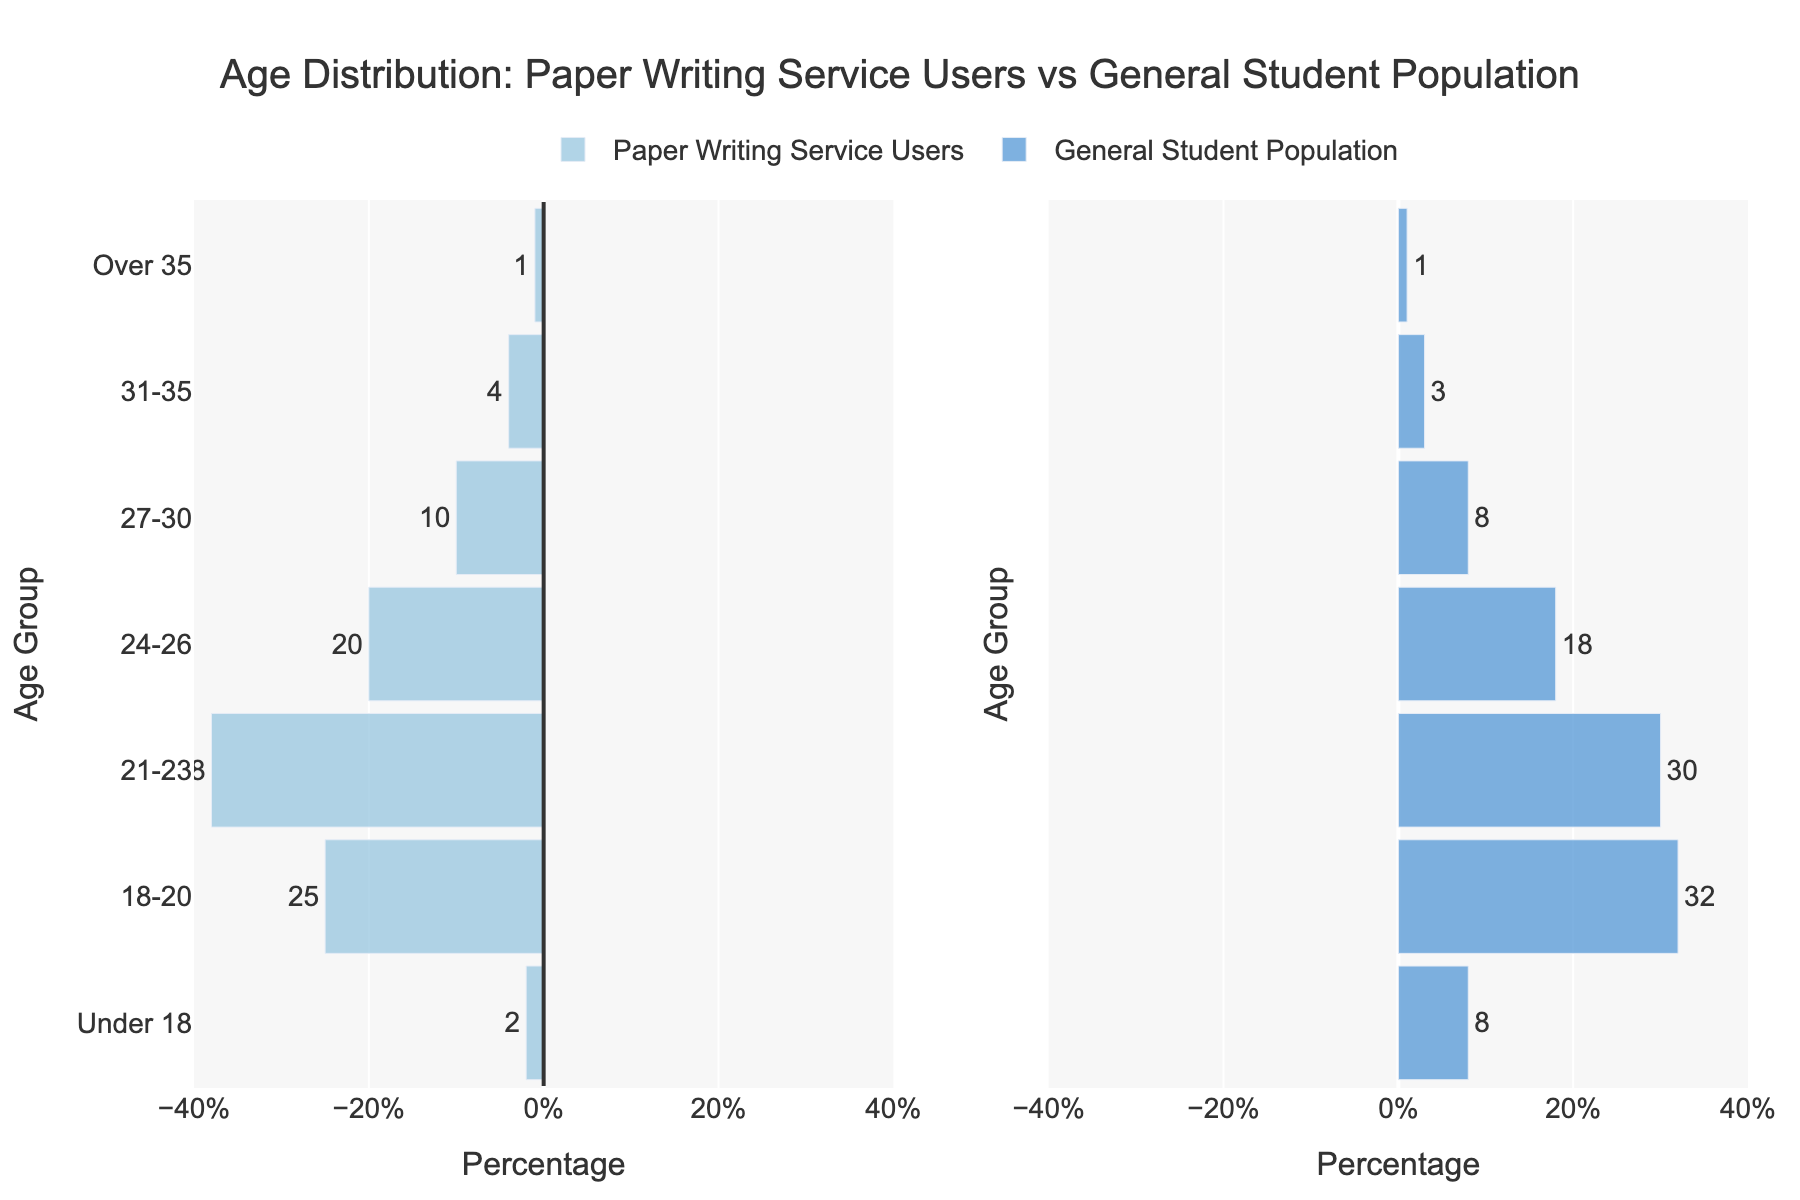what is the title of the figure? The title is displayed at the top of the figure, indicated with larger and bolder text. It summarizes what the figure is about.
Answer: Age Distribution: Paper Writing Service Users vs General Student Population How does the proportion of 18-20-year-old users of paper writing services compare to the general student population in the same age group? The bar for 18-20-year-olds in the Paper Writing Service Users category appears shorter than the bar for the same age group in the General Student Population. By comparing the numerical values, we see that 25% of paper writing service users are 18-20 years old, while 32% of the general student population falls within this age range.
Answer: Lower What is the difference in the percentage of 21-23-year-olds between the two groups? By looking at the length and values of the bars for the 21-23 age group, the Paper Writing Service Users have a percentage of 38%, while the General Student Population has 30%. Subtracting these two values (38 - 30) gives us the difference.
Answer: 8% Which age group has the smallest representation among paper writing service users? By examining the lengths of the bars within the Paper Writing Service Users category, the bar for the "Over 35" age group is the shortest, indicating the smallest percentage.
Answer: Over 35 What percentage of users of paper writing services are 24-30 years old? To find the total percentage of users aged 24-26 and 27-30, add their individual percentages. The figure shows 20% for 24-26-year-olds and 10% for 27-30-year-olds, summing up to 30%.
Answer: 30% Do older students (31 years and older) use paper writing services more or less than the general student population? Observing the bars for the "31-35" and "Over 35" age groups in both categories, we see that in Paper Writing Service Users, the percentages are 4% and 1%, respectively. For the General Student Population, the percentages are 3% and 1%, respectively. By comparing these percentages, we conclude that users of paper writing services actually use them more in the 31-35 age range but equally in the Over 35 range.
Answer: More for 31-35, Equal for Over 35 Which age group shows the biggest discrepancy in percentage between the two populations? By comparing the absolute differences for each age group, the difference is found by subtracting the smaller percentage from the larger for each age group. The largest difference can be easily seen in the figure by the relative lengths of the bars. 18-20 has the largest difference of 7% (32 - 25).
Answer: 18-20 Is there any age group where both populations have the same percentage representation? Viewing the lengths of the bars across both categories, we see that both groups have the same percentage only in the "Over 35" age group, where both are represented by 1%.
Answer: Over 35 What's the total representation of users under 24 years old in each group? Add the percentages of the "Under 18", "18-20", and "21-23" age groups separately for each population. For the Paper Writing Service Users: 2 + 25 + 38 = 65%. For the General Student Population: 8 + 32 + 30 = 70%.
Answer: 65% for Paper Writing Service Users, 70% for General Student Population 